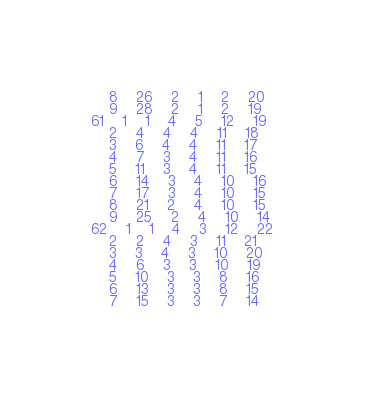<code> <loc_0><loc_0><loc_500><loc_500><_ObjectiveC_>	8	26	2	1	2	20	
	9	28	2	1	2	19	
61	1	1	4	5	12	19	
	2	4	4	4	11	18	
	3	6	4	4	11	17	
	4	7	3	4	11	16	
	5	11	3	4	11	15	
	6	14	3	4	10	16	
	7	17	3	4	10	15	
	8	21	2	4	10	15	
	9	25	2	4	10	14	
62	1	1	4	3	12	22	
	2	2	4	3	11	21	
	3	3	4	3	10	20	
	4	6	3	3	10	19	
	5	10	3	3	8	16	
	6	13	3	3	8	15	
	7	15	3	3	7	14	</code> 